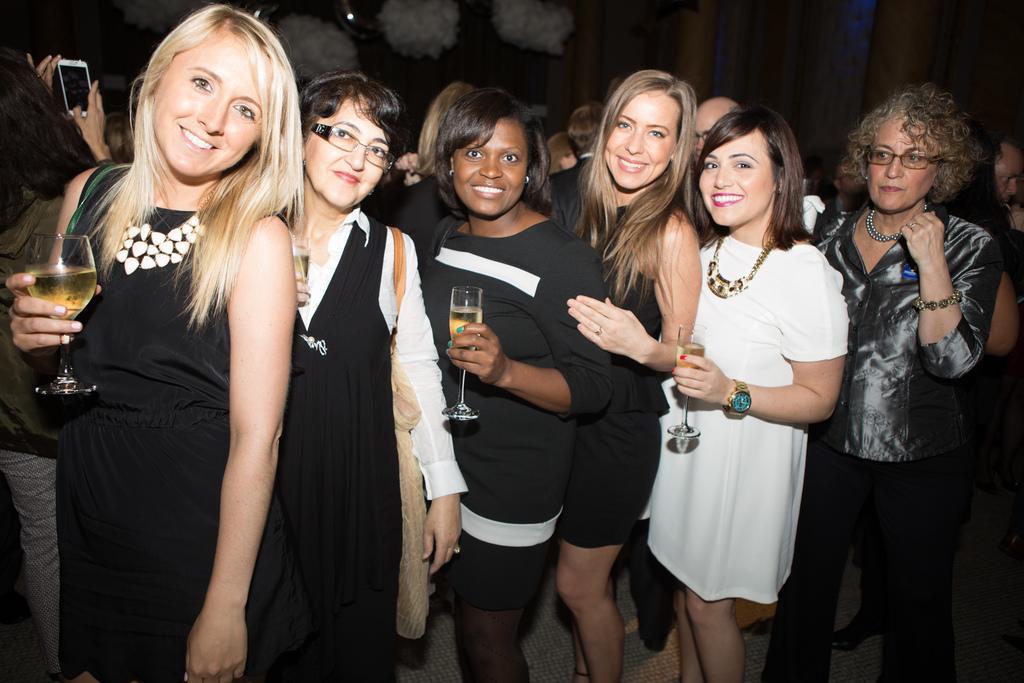Can you describe this image briefly? In the picture we can see these women wearing black dresses and a woman wearing white dress are holding glasses with a drink in it and standing here and smiling. In the background, we can see a few more people standing and the background of the image is dark. 